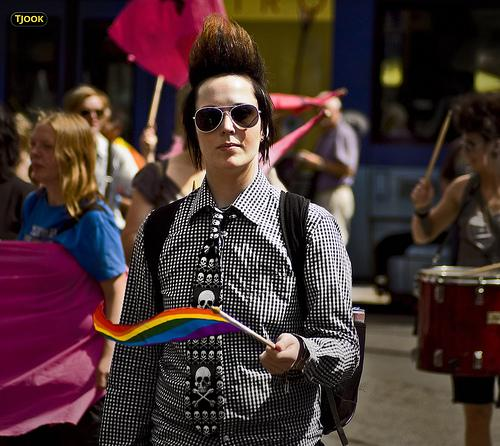Question: why is the woman carrying drumsticks?
Choices:
A. Someone asked her to bring them.
B. To play the drum.
C. Just in case someone needs extra ones.
D. She just bought them and is on her way home.
Answer with the letter. Answer: B Question: what is the man carrying in the photo?
Choices:
A. His son.
B. His lunch.
C. A flag.
D. A basket of fruit.
Answer with the letter. Answer: C Question: who is in the photo?
Choices:
A. People.
B. Abe Lincoln.
C. Partyers.
D. Ella Fitzgerald.
Answer with the letter. Answer: A Question: how many people are playing the drums?
Choices:
A. Two.
B. Three.
C. One.
D. Five.
Answer with the letter. Answer: C 